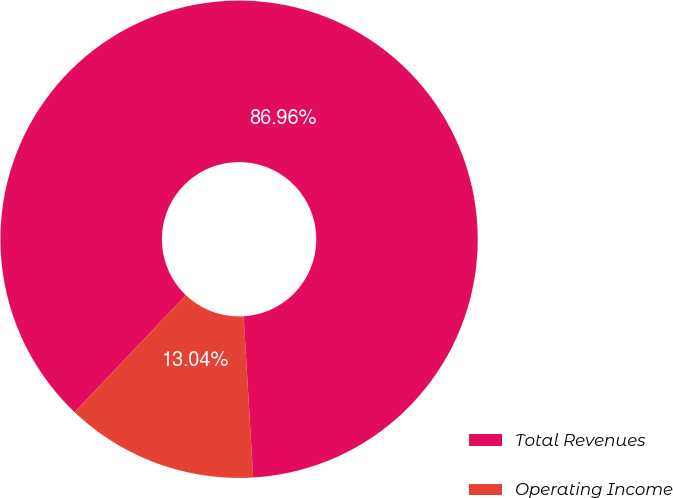Convert chart. <chart><loc_0><loc_0><loc_500><loc_500><pie_chart><fcel>Total Revenues<fcel>Operating Income<nl><fcel>86.96%<fcel>13.04%<nl></chart> 